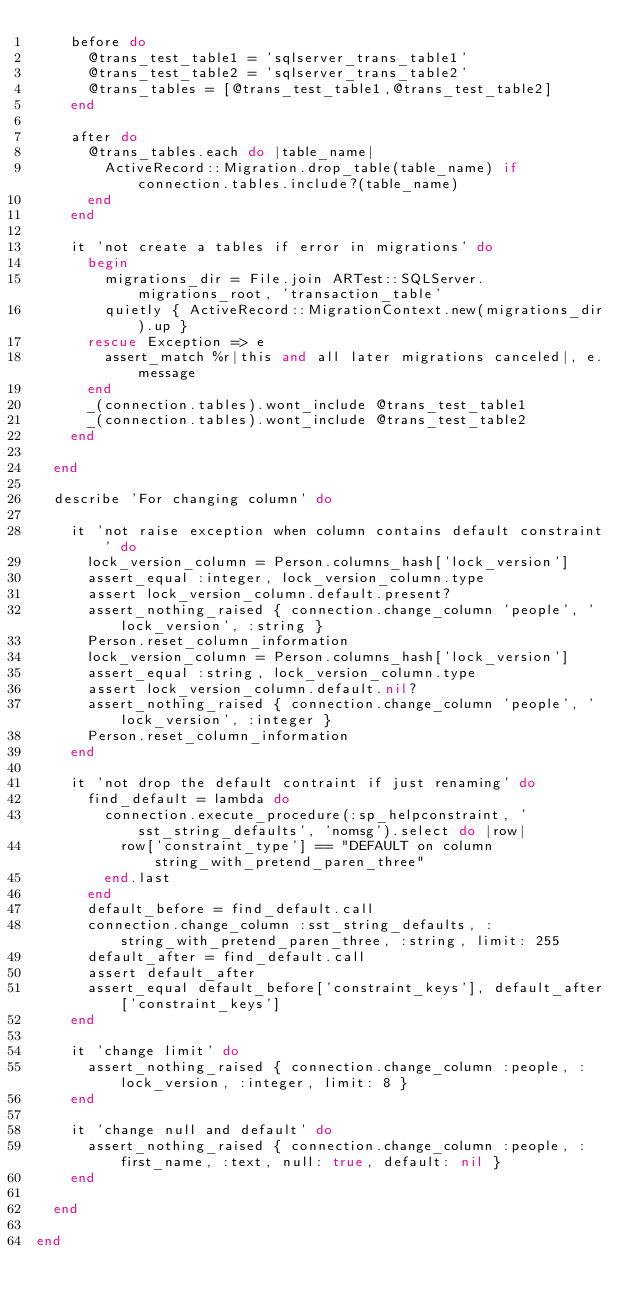Convert code to text. <code><loc_0><loc_0><loc_500><loc_500><_Ruby_>    before do
      @trans_test_table1 = 'sqlserver_trans_table1'
      @trans_test_table2 = 'sqlserver_trans_table2'
      @trans_tables = [@trans_test_table1,@trans_test_table2]
    end

    after do
      @trans_tables.each do |table_name|
        ActiveRecord::Migration.drop_table(table_name) if connection.tables.include?(table_name)
      end
    end

    it 'not create a tables if error in migrations' do
      begin
        migrations_dir = File.join ARTest::SQLServer.migrations_root, 'transaction_table'
        quietly { ActiveRecord::MigrationContext.new(migrations_dir).up }
      rescue Exception => e
        assert_match %r|this and all later migrations canceled|, e.message
      end
      _(connection.tables).wont_include @trans_test_table1
      _(connection.tables).wont_include @trans_test_table2
    end

  end

  describe 'For changing column' do

    it 'not raise exception when column contains default constraint' do
      lock_version_column = Person.columns_hash['lock_version']
      assert_equal :integer, lock_version_column.type
      assert lock_version_column.default.present?
      assert_nothing_raised { connection.change_column 'people', 'lock_version', :string }
      Person.reset_column_information
      lock_version_column = Person.columns_hash['lock_version']
      assert_equal :string, lock_version_column.type
      assert lock_version_column.default.nil?
      assert_nothing_raised { connection.change_column 'people', 'lock_version', :integer }
      Person.reset_column_information
    end

    it 'not drop the default contraint if just renaming' do
      find_default = lambda do
        connection.execute_procedure(:sp_helpconstraint, 'sst_string_defaults', 'nomsg').select do |row|
          row['constraint_type'] == "DEFAULT on column string_with_pretend_paren_three"
        end.last
      end
      default_before = find_default.call
      connection.change_column :sst_string_defaults, :string_with_pretend_paren_three, :string, limit: 255
      default_after = find_default.call
      assert default_after
      assert_equal default_before['constraint_keys'], default_after['constraint_keys']
    end
    
    it 'change limit' do
      assert_nothing_raised { connection.change_column :people, :lock_version, :integer, limit: 8 }
    end
    
    it 'change null and default' do
      assert_nothing_raised { connection.change_column :people, :first_name, :text, null: true, default: nil }
    end

  end

end
</code> 